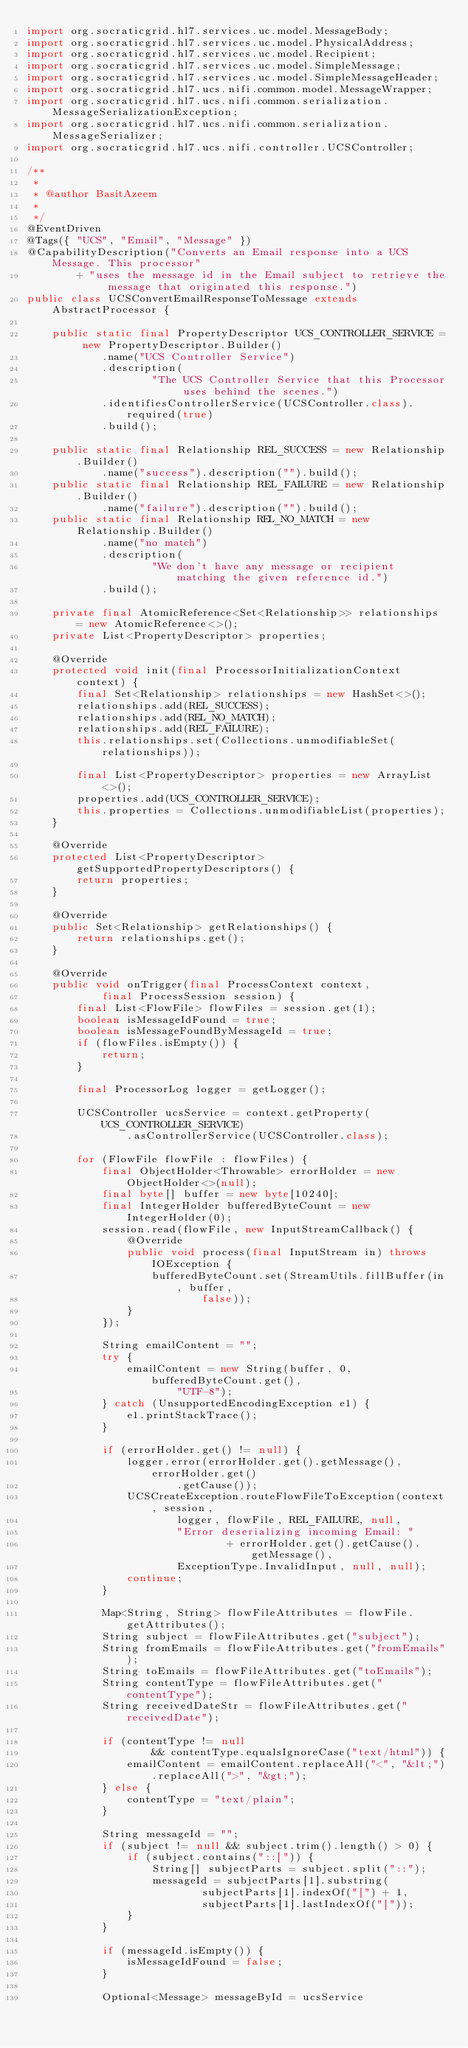Convert code to text. <code><loc_0><loc_0><loc_500><loc_500><_Java_>import org.socraticgrid.hl7.services.uc.model.MessageBody;
import org.socraticgrid.hl7.services.uc.model.PhysicalAddress;
import org.socraticgrid.hl7.services.uc.model.Recipient;
import org.socraticgrid.hl7.services.uc.model.SimpleMessage;
import org.socraticgrid.hl7.services.uc.model.SimpleMessageHeader;
import org.socraticgrid.hl7.ucs.nifi.common.model.MessageWrapper;
import org.socraticgrid.hl7.ucs.nifi.common.serialization.MessageSerializationException;
import org.socraticgrid.hl7.ucs.nifi.common.serialization.MessageSerializer;
import org.socraticgrid.hl7.ucs.nifi.controller.UCSController;

/**
 * 
 * @author BasitAzeem
 *
 */
@EventDriven
@Tags({ "UCS", "Email", "Message" })
@CapabilityDescription("Converts an Email response into a UCS Message. This processor"
		+ "uses the message id in the Email subject to retrieve the message that originated this response.")
public class UCSConvertEmailResponseToMessage extends AbstractProcessor {

	public static final PropertyDescriptor UCS_CONTROLLER_SERVICE = new PropertyDescriptor.Builder()
			.name("UCS Controller Service")
			.description(
					"The UCS Controller Service that this Processor uses behind the scenes.")
			.identifiesControllerService(UCSController.class).required(true)
			.build();

	public static final Relationship REL_SUCCESS = new Relationship.Builder()
			.name("success").description("").build();
	public static final Relationship REL_FAILURE = new Relationship.Builder()
			.name("failure").description("").build();
	public static final Relationship REL_NO_MATCH = new Relationship.Builder()
			.name("no match")
			.description(
					"We don't have any message or recipient matching the given reference id.")
			.build();

	private final AtomicReference<Set<Relationship>> relationships = new AtomicReference<>();
	private List<PropertyDescriptor> properties;

	@Override
	protected void init(final ProcessorInitializationContext context) {
		final Set<Relationship> relationships = new HashSet<>();
		relationships.add(REL_SUCCESS);
		relationships.add(REL_NO_MATCH);
		relationships.add(REL_FAILURE);
		this.relationships.set(Collections.unmodifiableSet(relationships));

		final List<PropertyDescriptor> properties = new ArrayList<>();
		properties.add(UCS_CONTROLLER_SERVICE);
		this.properties = Collections.unmodifiableList(properties);
	}

	@Override
	protected List<PropertyDescriptor> getSupportedPropertyDescriptors() {
		return properties;
	}

	@Override
	public Set<Relationship> getRelationships() {
		return relationships.get();
	}

	@Override
	public void onTrigger(final ProcessContext context,
			final ProcessSession session) {
		final List<FlowFile> flowFiles = session.get(1);
		boolean isMessageIdFound = true;
		boolean isMessageFoundByMessageId = true;
		if (flowFiles.isEmpty()) {
			return;
		}

		final ProcessorLog logger = getLogger();

		UCSController ucsService = context.getProperty(UCS_CONTROLLER_SERVICE)
				.asControllerService(UCSController.class);

		for (FlowFile flowFile : flowFiles) {
			final ObjectHolder<Throwable> errorHolder = new ObjectHolder<>(null);
			final byte[] buffer = new byte[10240];
			final IntegerHolder bufferedByteCount = new IntegerHolder(0);
			session.read(flowFile, new InputStreamCallback() {
				@Override
				public void process(final InputStream in) throws IOException {
					bufferedByteCount.set(StreamUtils.fillBuffer(in, buffer,
							false));
				}
			});

			String emailContent = "";
			try {
				emailContent = new String(buffer, 0, bufferedByteCount.get(),
						"UTF-8");
			} catch (UnsupportedEncodingException e1) {
				e1.printStackTrace();
			}

			if (errorHolder.get() != null) {
				logger.error(errorHolder.get().getMessage(), errorHolder.get()
						.getCause());
				UCSCreateException.routeFlowFileToException(context, session,
						logger, flowFile, REL_FAILURE, null,
						"Error deserializing incoming Email: "
								+ errorHolder.get().getCause().getMessage(),
						ExceptionType.InvalidInput, null, null);
				continue;
			}

			Map<String, String> flowFileAttributes = flowFile.getAttributes();
			String subject = flowFileAttributes.get("subject");
			String fromEmails = flowFileAttributes.get("fromEmails");
			String toEmails = flowFileAttributes.get("toEmails");
			String contentType = flowFileAttributes.get("contentType");
			String receivedDateStr = flowFileAttributes.get("receivedDate");

			if (contentType != null
					&& contentType.equalsIgnoreCase("text/html")) {
				emailContent = emailContent.replaceAll("<", "&lt;").replaceAll(">", "&gt;");
			} else {
				contentType = "text/plain";
			}

			String messageId = "";
			if (subject != null && subject.trim().length() > 0) {
				if (subject.contains("::[")) {
					String[] subjectParts = subject.split("::");
					messageId = subjectParts[1].substring(
							subjectParts[1].indexOf("[") + 1,
							subjectParts[1].lastIndexOf("]"));
				}
			}

			if (messageId.isEmpty()) {
				isMessageIdFound = false;
			}

			Optional<Message> messageById = ucsService</code> 